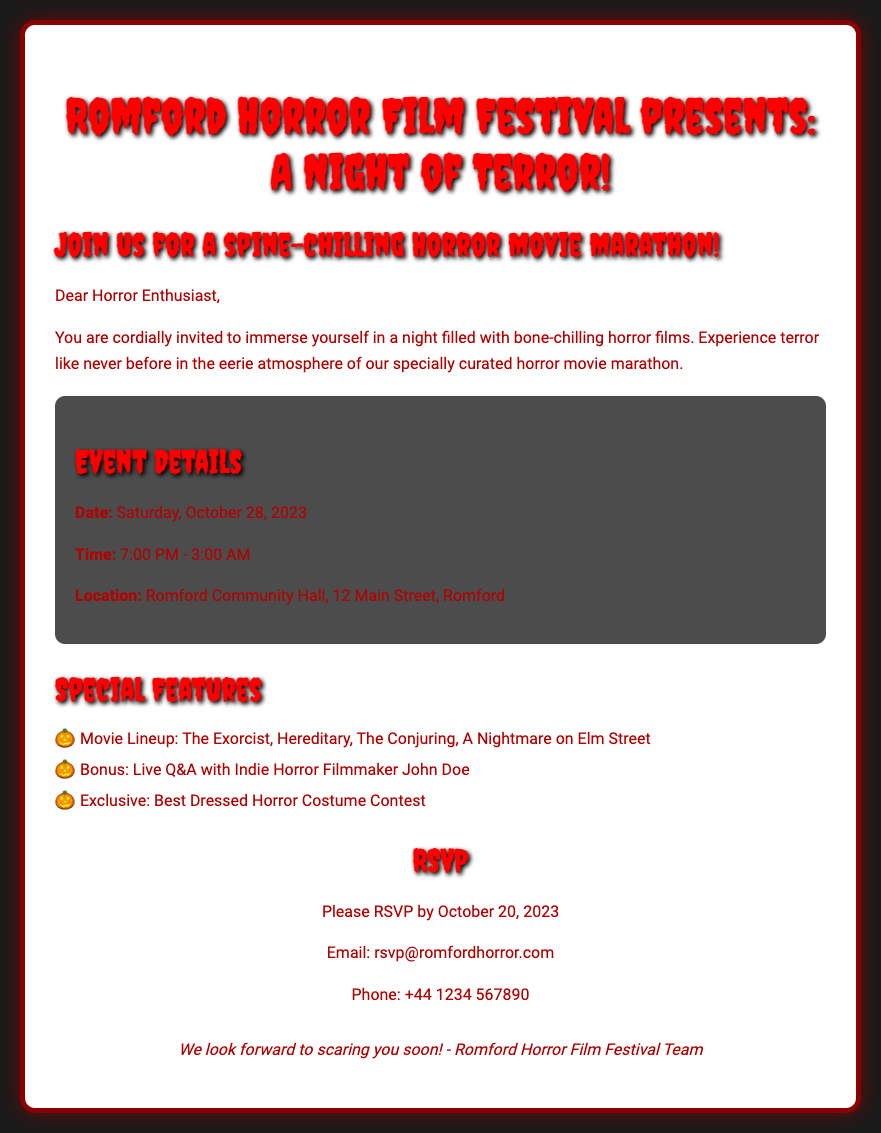What is the date of the event? The date of the event is explicitly stated in the document.
Answer: Saturday, October 28, 2023 What time does the event start? The starting time for the event is mentioned in the document.
Answer: 7:00 PM Where is the event being held? The location of the event is provided in the event details section of the document.
Answer: Romford Community Hall, 12 Main Street, Romford Who is the filmmaker participating in the live Q&A? The document specifies the name of the indie horror filmmaker featured in the event.
Answer: John Doe What are the special features listed in the document? The document outlines specific entertainment features associated with the event.
Answer: Movie Lineup, Live Q&A, Best Dressed Horror Costume Contest What is the RSVP deadline? The deadline for RSVPing is clearly mentioned in the document.
Answer: October 20, 2023 What theme is emphasized for the card's design? The aesthetics of the card highlight a particular theme that fits the horror genre.
Answer: Eerie graveyard illustration What is the contact email for RSVPs? The document lists a specific email for attendees to confirm their participation.
Answer: rsvp@romfordhorror.com 